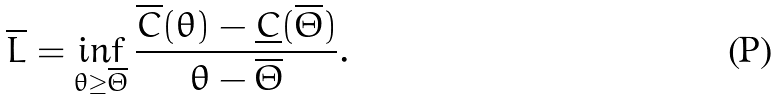<formula> <loc_0><loc_0><loc_500><loc_500>\overline { L } = \inf _ { \theta \geq \overline { \Theta } } \frac { \overline { C } ( \theta ) - \underline { C } ( \overline { \Theta } ) } { \theta - \overline { \Theta } } .</formula> 